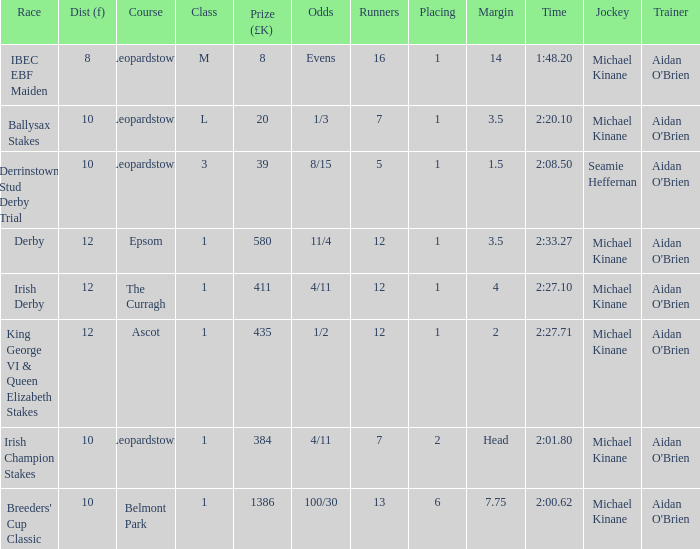Which Class has a Jockey of michael kinane on 2:27.71? 1.0. 